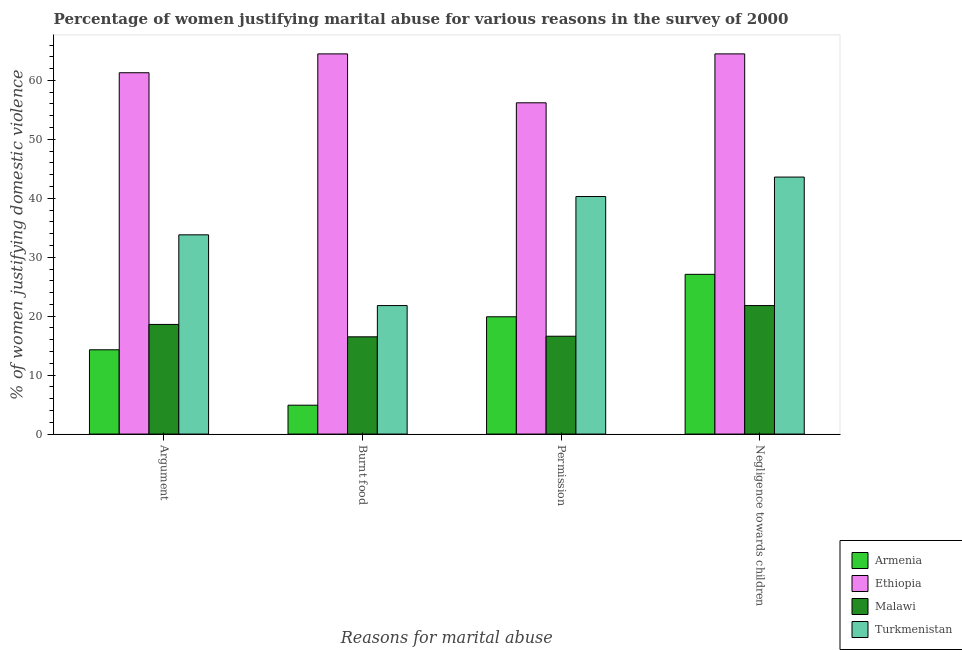What is the label of the 3rd group of bars from the left?
Give a very brief answer. Permission. What is the percentage of women justifying abuse in the case of an argument in Malawi?
Your answer should be very brief. 18.6. Across all countries, what is the maximum percentage of women justifying abuse for burning food?
Your answer should be compact. 64.5. In which country was the percentage of women justifying abuse for burning food maximum?
Give a very brief answer. Ethiopia. In which country was the percentage of women justifying abuse for showing negligence towards children minimum?
Make the answer very short. Malawi. What is the total percentage of women justifying abuse for showing negligence towards children in the graph?
Keep it short and to the point. 157. What is the difference between the percentage of women justifying abuse for going without permission in Ethiopia and that in Turkmenistan?
Offer a terse response. 15.9. What is the difference between the percentage of women justifying abuse for going without permission in Armenia and the percentage of women justifying abuse in the case of an argument in Turkmenistan?
Keep it short and to the point. -13.9. What is the average percentage of women justifying abuse in the case of an argument per country?
Your answer should be very brief. 32. What is the difference between the percentage of women justifying abuse in the case of an argument and percentage of women justifying abuse for showing negligence towards children in Turkmenistan?
Make the answer very short. -9.8. In how many countries, is the percentage of women justifying abuse for burning food greater than 22 %?
Offer a terse response. 1. What is the ratio of the percentage of women justifying abuse for going without permission in Ethiopia to that in Malawi?
Keep it short and to the point. 3.39. Is the percentage of women justifying abuse for showing negligence towards children in Armenia less than that in Turkmenistan?
Ensure brevity in your answer.  Yes. What is the difference between the highest and the second highest percentage of women justifying abuse for burning food?
Provide a short and direct response. 42.7. What is the difference between the highest and the lowest percentage of women justifying abuse in the case of an argument?
Your answer should be very brief. 47. In how many countries, is the percentage of women justifying abuse in the case of an argument greater than the average percentage of women justifying abuse in the case of an argument taken over all countries?
Give a very brief answer. 2. Is the sum of the percentage of women justifying abuse for showing negligence towards children in Turkmenistan and Ethiopia greater than the maximum percentage of women justifying abuse for going without permission across all countries?
Provide a succinct answer. Yes. Is it the case that in every country, the sum of the percentage of women justifying abuse in the case of an argument and percentage of women justifying abuse for showing negligence towards children is greater than the sum of percentage of women justifying abuse for going without permission and percentage of women justifying abuse for burning food?
Your response must be concise. No. What does the 2nd bar from the left in Burnt food represents?
Give a very brief answer. Ethiopia. What does the 4th bar from the right in Negligence towards children represents?
Make the answer very short. Armenia. How many bars are there?
Keep it short and to the point. 16. Are all the bars in the graph horizontal?
Provide a succinct answer. No. How many countries are there in the graph?
Provide a short and direct response. 4. What is the difference between two consecutive major ticks on the Y-axis?
Keep it short and to the point. 10. Are the values on the major ticks of Y-axis written in scientific E-notation?
Your answer should be compact. No. Does the graph contain any zero values?
Your answer should be compact. No. How many legend labels are there?
Offer a terse response. 4. How are the legend labels stacked?
Offer a very short reply. Vertical. What is the title of the graph?
Keep it short and to the point. Percentage of women justifying marital abuse for various reasons in the survey of 2000. What is the label or title of the X-axis?
Your answer should be very brief. Reasons for marital abuse. What is the label or title of the Y-axis?
Your response must be concise. % of women justifying domestic violence. What is the % of women justifying domestic violence of Ethiopia in Argument?
Your answer should be compact. 61.3. What is the % of women justifying domestic violence of Malawi in Argument?
Provide a short and direct response. 18.6. What is the % of women justifying domestic violence in Turkmenistan in Argument?
Give a very brief answer. 33.8. What is the % of women justifying domestic violence in Ethiopia in Burnt food?
Provide a succinct answer. 64.5. What is the % of women justifying domestic violence in Malawi in Burnt food?
Provide a short and direct response. 16.5. What is the % of women justifying domestic violence of Turkmenistan in Burnt food?
Ensure brevity in your answer.  21.8. What is the % of women justifying domestic violence of Ethiopia in Permission?
Your response must be concise. 56.2. What is the % of women justifying domestic violence in Malawi in Permission?
Your answer should be compact. 16.6. What is the % of women justifying domestic violence of Turkmenistan in Permission?
Make the answer very short. 40.3. What is the % of women justifying domestic violence of Armenia in Negligence towards children?
Offer a very short reply. 27.1. What is the % of women justifying domestic violence of Ethiopia in Negligence towards children?
Provide a short and direct response. 64.5. What is the % of women justifying domestic violence in Malawi in Negligence towards children?
Your response must be concise. 21.8. What is the % of women justifying domestic violence of Turkmenistan in Negligence towards children?
Offer a terse response. 43.6. Across all Reasons for marital abuse, what is the maximum % of women justifying domestic violence in Armenia?
Ensure brevity in your answer.  27.1. Across all Reasons for marital abuse, what is the maximum % of women justifying domestic violence in Ethiopia?
Your response must be concise. 64.5. Across all Reasons for marital abuse, what is the maximum % of women justifying domestic violence in Malawi?
Make the answer very short. 21.8. Across all Reasons for marital abuse, what is the maximum % of women justifying domestic violence in Turkmenistan?
Make the answer very short. 43.6. Across all Reasons for marital abuse, what is the minimum % of women justifying domestic violence of Armenia?
Your answer should be compact. 4.9. Across all Reasons for marital abuse, what is the minimum % of women justifying domestic violence in Ethiopia?
Make the answer very short. 56.2. Across all Reasons for marital abuse, what is the minimum % of women justifying domestic violence of Malawi?
Offer a terse response. 16.5. Across all Reasons for marital abuse, what is the minimum % of women justifying domestic violence in Turkmenistan?
Provide a short and direct response. 21.8. What is the total % of women justifying domestic violence in Armenia in the graph?
Offer a terse response. 66.2. What is the total % of women justifying domestic violence of Ethiopia in the graph?
Keep it short and to the point. 246.5. What is the total % of women justifying domestic violence in Malawi in the graph?
Provide a short and direct response. 73.5. What is the total % of women justifying domestic violence of Turkmenistan in the graph?
Ensure brevity in your answer.  139.5. What is the difference between the % of women justifying domestic violence in Armenia in Argument and that in Burnt food?
Your answer should be very brief. 9.4. What is the difference between the % of women justifying domestic violence of Malawi in Argument and that in Burnt food?
Ensure brevity in your answer.  2.1. What is the difference between the % of women justifying domestic violence of Armenia in Argument and that in Permission?
Keep it short and to the point. -5.6. What is the difference between the % of women justifying domestic violence in Ethiopia in Argument and that in Permission?
Offer a very short reply. 5.1. What is the difference between the % of women justifying domestic violence of Armenia in Argument and that in Negligence towards children?
Ensure brevity in your answer.  -12.8. What is the difference between the % of women justifying domestic violence of Ethiopia in Argument and that in Negligence towards children?
Give a very brief answer. -3.2. What is the difference between the % of women justifying domestic violence of Malawi in Argument and that in Negligence towards children?
Your answer should be compact. -3.2. What is the difference between the % of women justifying domestic violence in Turkmenistan in Argument and that in Negligence towards children?
Make the answer very short. -9.8. What is the difference between the % of women justifying domestic violence of Armenia in Burnt food and that in Permission?
Give a very brief answer. -15. What is the difference between the % of women justifying domestic violence in Malawi in Burnt food and that in Permission?
Your answer should be very brief. -0.1. What is the difference between the % of women justifying domestic violence in Turkmenistan in Burnt food and that in Permission?
Keep it short and to the point. -18.5. What is the difference between the % of women justifying domestic violence of Armenia in Burnt food and that in Negligence towards children?
Keep it short and to the point. -22.2. What is the difference between the % of women justifying domestic violence in Turkmenistan in Burnt food and that in Negligence towards children?
Give a very brief answer. -21.8. What is the difference between the % of women justifying domestic violence of Armenia in Permission and that in Negligence towards children?
Offer a very short reply. -7.2. What is the difference between the % of women justifying domestic violence of Ethiopia in Permission and that in Negligence towards children?
Provide a succinct answer. -8.3. What is the difference between the % of women justifying domestic violence of Malawi in Permission and that in Negligence towards children?
Your answer should be compact. -5.2. What is the difference between the % of women justifying domestic violence in Armenia in Argument and the % of women justifying domestic violence in Ethiopia in Burnt food?
Make the answer very short. -50.2. What is the difference between the % of women justifying domestic violence of Armenia in Argument and the % of women justifying domestic violence of Malawi in Burnt food?
Provide a succinct answer. -2.2. What is the difference between the % of women justifying domestic violence in Ethiopia in Argument and the % of women justifying domestic violence in Malawi in Burnt food?
Make the answer very short. 44.8. What is the difference between the % of women justifying domestic violence in Ethiopia in Argument and the % of women justifying domestic violence in Turkmenistan in Burnt food?
Ensure brevity in your answer.  39.5. What is the difference between the % of women justifying domestic violence of Malawi in Argument and the % of women justifying domestic violence of Turkmenistan in Burnt food?
Offer a terse response. -3.2. What is the difference between the % of women justifying domestic violence of Armenia in Argument and the % of women justifying domestic violence of Ethiopia in Permission?
Provide a short and direct response. -41.9. What is the difference between the % of women justifying domestic violence in Armenia in Argument and the % of women justifying domestic violence in Malawi in Permission?
Keep it short and to the point. -2.3. What is the difference between the % of women justifying domestic violence of Ethiopia in Argument and the % of women justifying domestic violence of Malawi in Permission?
Your response must be concise. 44.7. What is the difference between the % of women justifying domestic violence of Ethiopia in Argument and the % of women justifying domestic violence of Turkmenistan in Permission?
Keep it short and to the point. 21. What is the difference between the % of women justifying domestic violence of Malawi in Argument and the % of women justifying domestic violence of Turkmenistan in Permission?
Make the answer very short. -21.7. What is the difference between the % of women justifying domestic violence in Armenia in Argument and the % of women justifying domestic violence in Ethiopia in Negligence towards children?
Your answer should be compact. -50.2. What is the difference between the % of women justifying domestic violence in Armenia in Argument and the % of women justifying domestic violence in Malawi in Negligence towards children?
Keep it short and to the point. -7.5. What is the difference between the % of women justifying domestic violence in Armenia in Argument and the % of women justifying domestic violence in Turkmenistan in Negligence towards children?
Offer a terse response. -29.3. What is the difference between the % of women justifying domestic violence in Ethiopia in Argument and the % of women justifying domestic violence in Malawi in Negligence towards children?
Give a very brief answer. 39.5. What is the difference between the % of women justifying domestic violence in Ethiopia in Argument and the % of women justifying domestic violence in Turkmenistan in Negligence towards children?
Provide a succinct answer. 17.7. What is the difference between the % of women justifying domestic violence in Armenia in Burnt food and the % of women justifying domestic violence in Ethiopia in Permission?
Give a very brief answer. -51.3. What is the difference between the % of women justifying domestic violence of Armenia in Burnt food and the % of women justifying domestic violence of Turkmenistan in Permission?
Offer a very short reply. -35.4. What is the difference between the % of women justifying domestic violence in Ethiopia in Burnt food and the % of women justifying domestic violence in Malawi in Permission?
Offer a very short reply. 47.9. What is the difference between the % of women justifying domestic violence of Ethiopia in Burnt food and the % of women justifying domestic violence of Turkmenistan in Permission?
Provide a succinct answer. 24.2. What is the difference between the % of women justifying domestic violence of Malawi in Burnt food and the % of women justifying domestic violence of Turkmenistan in Permission?
Provide a short and direct response. -23.8. What is the difference between the % of women justifying domestic violence in Armenia in Burnt food and the % of women justifying domestic violence in Ethiopia in Negligence towards children?
Keep it short and to the point. -59.6. What is the difference between the % of women justifying domestic violence of Armenia in Burnt food and the % of women justifying domestic violence of Malawi in Negligence towards children?
Keep it short and to the point. -16.9. What is the difference between the % of women justifying domestic violence of Armenia in Burnt food and the % of women justifying domestic violence of Turkmenistan in Negligence towards children?
Your answer should be very brief. -38.7. What is the difference between the % of women justifying domestic violence in Ethiopia in Burnt food and the % of women justifying domestic violence in Malawi in Negligence towards children?
Provide a succinct answer. 42.7. What is the difference between the % of women justifying domestic violence of Ethiopia in Burnt food and the % of women justifying domestic violence of Turkmenistan in Negligence towards children?
Your answer should be very brief. 20.9. What is the difference between the % of women justifying domestic violence of Malawi in Burnt food and the % of women justifying domestic violence of Turkmenistan in Negligence towards children?
Your response must be concise. -27.1. What is the difference between the % of women justifying domestic violence in Armenia in Permission and the % of women justifying domestic violence in Ethiopia in Negligence towards children?
Your response must be concise. -44.6. What is the difference between the % of women justifying domestic violence of Armenia in Permission and the % of women justifying domestic violence of Turkmenistan in Negligence towards children?
Offer a very short reply. -23.7. What is the difference between the % of women justifying domestic violence of Ethiopia in Permission and the % of women justifying domestic violence of Malawi in Negligence towards children?
Ensure brevity in your answer.  34.4. What is the average % of women justifying domestic violence in Armenia per Reasons for marital abuse?
Provide a short and direct response. 16.55. What is the average % of women justifying domestic violence in Ethiopia per Reasons for marital abuse?
Your response must be concise. 61.62. What is the average % of women justifying domestic violence in Malawi per Reasons for marital abuse?
Make the answer very short. 18.38. What is the average % of women justifying domestic violence of Turkmenistan per Reasons for marital abuse?
Keep it short and to the point. 34.88. What is the difference between the % of women justifying domestic violence in Armenia and % of women justifying domestic violence in Ethiopia in Argument?
Your answer should be very brief. -47. What is the difference between the % of women justifying domestic violence in Armenia and % of women justifying domestic violence in Malawi in Argument?
Make the answer very short. -4.3. What is the difference between the % of women justifying domestic violence of Armenia and % of women justifying domestic violence of Turkmenistan in Argument?
Ensure brevity in your answer.  -19.5. What is the difference between the % of women justifying domestic violence of Ethiopia and % of women justifying domestic violence of Malawi in Argument?
Provide a succinct answer. 42.7. What is the difference between the % of women justifying domestic violence in Malawi and % of women justifying domestic violence in Turkmenistan in Argument?
Provide a short and direct response. -15.2. What is the difference between the % of women justifying domestic violence in Armenia and % of women justifying domestic violence in Ethiopia in Burnt food?
Give a very brief answer. -59.6. What is the difference between the % of women justifying domestic violence in Armenia and % of women justifying domestic violence in Turkmenistan in Burnt food?
Offer a terse response. -16.9. What is the difference between the % of women justifying domestic violence in Ethiopia and % of women justifying domestic violence in Malawi in Burnt food?
Ensure brevity in your answer.  48. What is the difference between the % of women justifying domestic violence of Ethiopia and % of women justifying domestic violence of Turkmenistan in Burnt food?
Your answer should be compact. 42.7. What is the difference between the % of women justifying domestic violence in Malawi and % of women justifying domestic violence in Turkmenistan in Burnt food?
Ensure brevity in your answer.  -5.3. What is the difference between the % of women justifying domestic violence in Armenia and % of women justifying domestic violence in Ethiopia in Permission?
Keep it short and to the point. -36.3. What is the difference between the % of women justifying domestic violence of Armenia and % of women justifying domestic violence of Malawi in Permission?
Keep it short and to the point. 3.3. What is the difference between the % of women justifying domestic violence in Armenia and % of women justifying domestic violence in Turkmenistan in Permission?
Offer a terse response. -20.4. What is the difference between the % of women justifying domestic violence in Ethiopia and % of women justifying domestic violence in Malawi in Permission?
Ensure brevity in your answer.  39.6. What is the difference between the % of women justifying domestic violence in Ethiopia and % of women justifying domestic violence in Turkmenistan in Permission?
Provide a succinct answer. 15.9. What is the difference between the % of women justifying domestic violence in Malawi and % of women justifying domestic violence in Turkmenistan in Permission?
Ensure brevity in your answer.  -23.7. What is the difference between the % of women justifying domestic violence of Armenia and % of women justifying domestic violence of Ethiopia in Negligence towards children?
Your response must be concise. -37.4. What is the difference between the % of women justifying domestic violence in Armenia and % of women justifying domestic violence in Malawi in Negligence towards children?
Provide a short and direct response. 5.3. What is the difference between the % of women justifying domestic violence in Armenia and % of women justifying domestic violence in Turkmenistan in Negligence towards children?
Offer a very short reply. -16.5. What is the difference between the % of women justifying domestic violence of Ethiopia and % of women justifying domestic violence of Malawi in Negligence towards children?
Provide a short and direct response. 42.7. What is the difference between the % of women justifying domestic violence in Ethiopia and % of women justifying domestic violence in Turkmenistan in Negligence towards children?
Your answer should be compact. 20.9. What is the difference between the % of women justifying domestic violence of Malawi and % of women justifying domestic violence of Turkmenistan in Negligence towards children?
Provide a short and direct response. -21.8. What is the ratio of the % of women justifying domestic violence in Armenia in Argument to that in Burnt food?
Provide a succinct answer. 2.92. What is the ratio of the % of women justifying domestic violence in Ethiopia in Argument to that in Burnt food?
Ensure brevity in your answer.  0.95. What is the ratio of the % of women justifying domestic violence in Malawi in Argument to that in Burnt food?
Offer a very short reply. 1.13. What is the ratio of the % of women justifying domestic violence in Turkmenistan in Argument to that in Burnt food?
Make the answer very short. 1.55. What is the ratio of the % of women justifying domestic violence of Armenia in Argument to that in Permission?
Provide a succinct answer. 0.72. What is the ratio of the % of women justifying domestic violence in Ethiopia in Argument to that in Permission?
Your answer should be compact. 1.09. What is the ratio of the % of women justifying domestic violence of Malawi in Argument to that in Permission?
Provide a succinct answer. 1.12. What is the ratio of the % of women justifying domestic violence of Turkmenistan in Argument to that in Permission?
Offer a terse response. 0.84. What is the ratio of the % of women justifying domestic violence of Armenia in Argument to that in Negligence towards children?
Provide a short and direct response. 0.53. What is the ratio of the % of women justifying domestic violence in Ethiopia in Argument to that in Negligence towards children?
Give a very brief answer. 0.95. What is the ratio of the % of women justifying domestic violence of Malawi in Argument to that in Negligence towards children?
Your response must be concise. 0.85. What is the ratio of the % of women justifying domestic violence of Turkmenistan in Argument to that in Negligence towards children?
Ensure brevity in your answer.  0.78. What is the ratio of the % of women justifying domestic violence in Armenia in Burnt food to that in Permission?
Offer a very short reply. 0.25. What is the ratio of the % of women justifying domestic violence in Ethiopia in Burnt food to that in Permission?
Keep it short and to the point. 1.15. What is the ratio of the % of women justifying domestic violence in Turkmenistan in Burnt food to that in Permission?
Make the answer very short. 0.54. What is the ratio of the % of women justifying domestic violence of Armenia in Burnt food to that in Negligence towards children?
Give a very brief answer. 0.18. What is the ratio of the % of women justifying domestic violence in Ethiopia in Burnt food to that in Negligence towards children?
Ensure brevity in your answer.  1. What is the ratio of the % of women justifying domestic violence of Malawi in Burnt food to that in Negligence towards children?
Offer a very short reply. 0.76. What is the ratio of the % of women justifying domestic violence in Turkmenistan in Burnt food to that in Negligence towards children?
Provide a short and direct response. 0.5. What is the ratio of the % of women justifying domestic violence in Armenia in Permission to that in Negligence towards children?
Give a very brief answer. 0.73. What is the ratio of the % of women justifying domestic violence in Ethiopia in Permission to that in Negligence towards children?
Your answer should be compact. 0.87. What is the ratio of the % of women justifying domestic violence of Malawi in Permission to that in Negligence towards children?
Provide a succinct answer. 0.76. What is the ratio of the % of women justifying domestic violence in Turkmenistan in Permission to that in Negligence towards children?
Make the answer very short. 0.92. What is the difference between the highest and the second highest % of women justifying domestic violence of Malawi?
Give a very brief answer. 3.2. What is the difference between the highest and the second highest % of women justifying domestic violence of Turkmenistan?
Your response must be concise. 3.3. What is the difference between the highest and the lowest % of women justifying domestic violence in Ethiopia?
Your answer should be very brief. 8.3. What is the difference between the highest and the lowest % of women justifying domestic violence in Turkmenistan?
Provide a succinct answer. 21.8. 